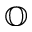<formula> <loc_0><loc_0><loc_500><loc_500>\mathbb { O }</formula> 